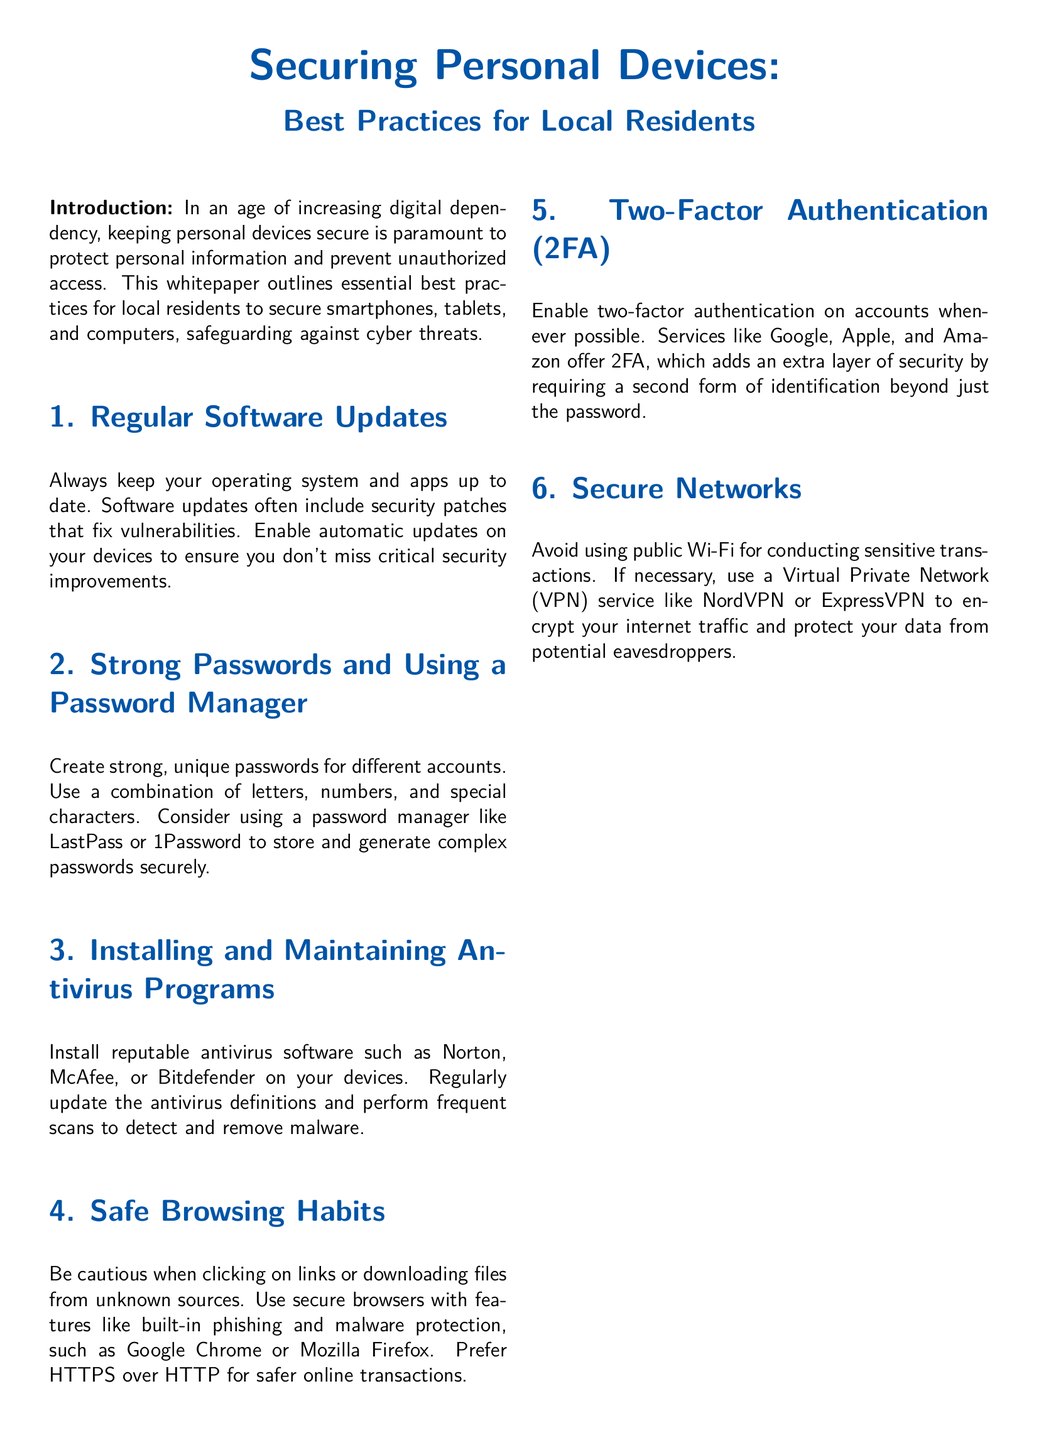What is the main focus of the whitepaper? The whitepaper outlines essential best practices for local residents to secure smartphones, tablets, and computers, safeguarding against cyber threats.
Answer: Securing personal devices What should be enabled to ensure you don't miss critical security improvements? Enabling this feature helps to automatically keep devices updated without user intervention.
Answer: Automatic updates What is a suggested action to enhance passwords? This practice helps users create and manage complex passwords securely.
Answer: Using a password manager Name one reputable antivirus software mentioned. The document lists several options for antivirus software that users can install.
Answer: Norton What is recommended to perform regularly in addition to installing antivirus software? This action is necessary to detect and remove malware from devices effectively.
Answer: Frequent scans What extra layer of security does two-factor authentication provide? This method ensures another form of identification is required beyond just a password.
Answer: Extra layer of security What type of network should be avoided for sensitive transactions? The document suggests that this type of network can expose users to greater risks.
Answer: Public Wi-Fi What is one service recommended for encrypting internet traffic? The document offers a suggestion to help secure data while browsing.
Answer: VPN What should you prefer for safer online transactions? This webpage designation is known for providing better security during online activities.
Answer: HTTPS 